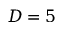Convert formula to latex. <formula><loc_0><loc_0><loc_500><loc_500>D = 5</formula> 